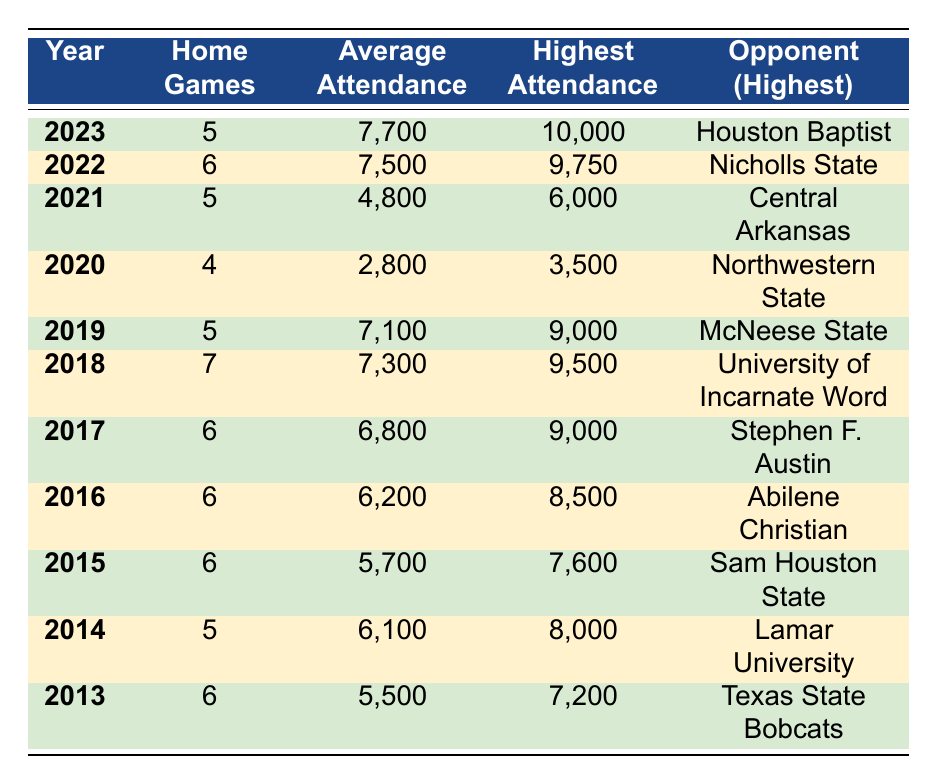What was the highest attendance recorded in 2023? Referring to the 2023 row in the table, the highest attendance is listed as 10,000.
Answer: 10,000 What is the average attendance for the year with the fewest home games? The year with the fewest home games is 2020, which had 4 home games. The average attendance for that year is 2,800.
Answer: 2,800 Did average attendance increase every year from 2013 to 2019? Looking at the average attendance from 2013 (5,500) to 2019 (7,100), the attendance does not consistently increase. For example, 2015 saw a decrease to 5,700 from 2014's 6,100. Thus, average attendance did not increase every year.
Answer: No What is the difference in average attendance between 2016 and 2018? The average attendance in 2016 is 6,200 and in 2018 is 7,300. The difference is 7,300 - 6,200 = 1,100.
Answer: 1,100 In which year did Southwest Texas State have the highest average attendance? By reviewing the average attendance for each year, we see that 2023 had the highest average attendance of 7,700.
Answer: 2023 What is the total number of home games played in the years where the average attendance was above 6,000? The years with average attendance above 6,000 are 2014 (5), 2016 (6), 2017 (6), 2018 (7), 2019 (5), 2022 (6), and 2023 (5). Adding these gives 5 + 6 + 6 + 7 + 5 + 6 + 5 = 40.
Answer: 40 Was the lowest attendance in 2020 higher than in 2013? In 2020, the lowest attendance is listed as 1,500 and in 2013, it is 3,200. Therefore, the lowest in 2020 is not higher than in 2013.
Answer: No What is the average attendance of all home games in 2021 and 2022 combined? For 2021, the average attendance is 4,800, and for 2022, it is 7,500. Adding these gives 4,800 + 7,500 = 12,300. To find the average, we divide by 2 (for the two years), resulting in 12,300 / 2 = 6,150.
Answer: 6,150 